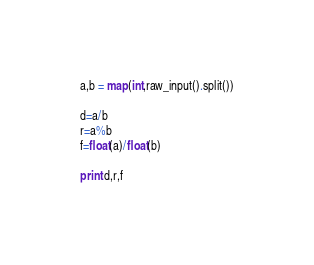Convert code to text. <code><loc_0><loc_0><loc_500><loc_500><_Python_>a,b = map(int,raw_input().split())

d=a/b
r=a%b
f=float(a)/float(b)

print d,r,f</code> 